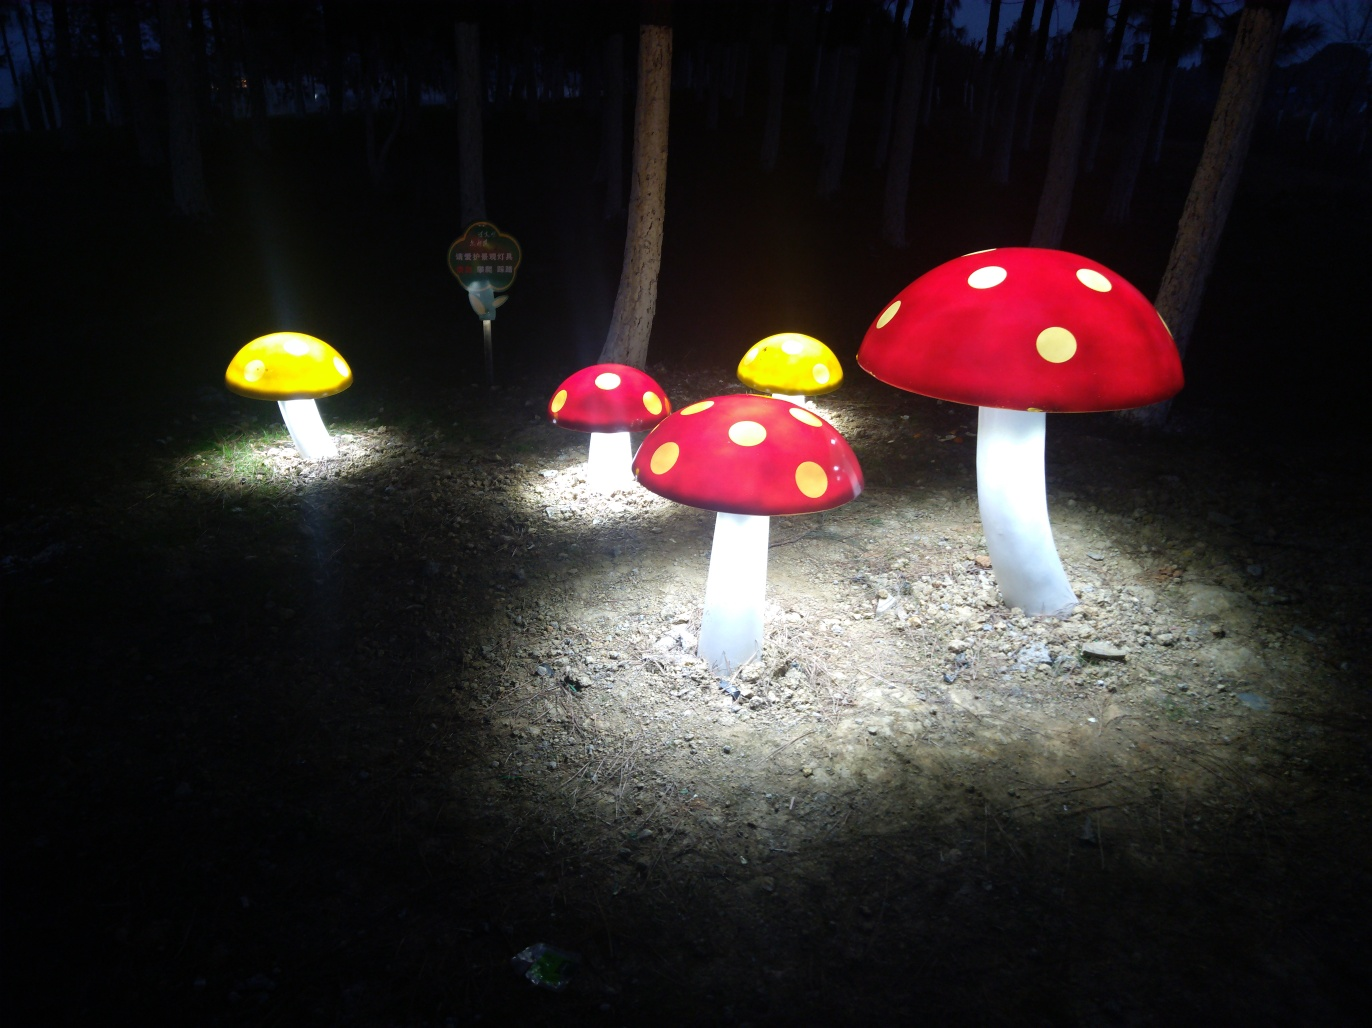What can you tell me about the mushrooms in the image? These mushrooms are not natural; they are artificial structures that are likely part of an outdoor installation or display, evident from their bright colors and internal illumination. 